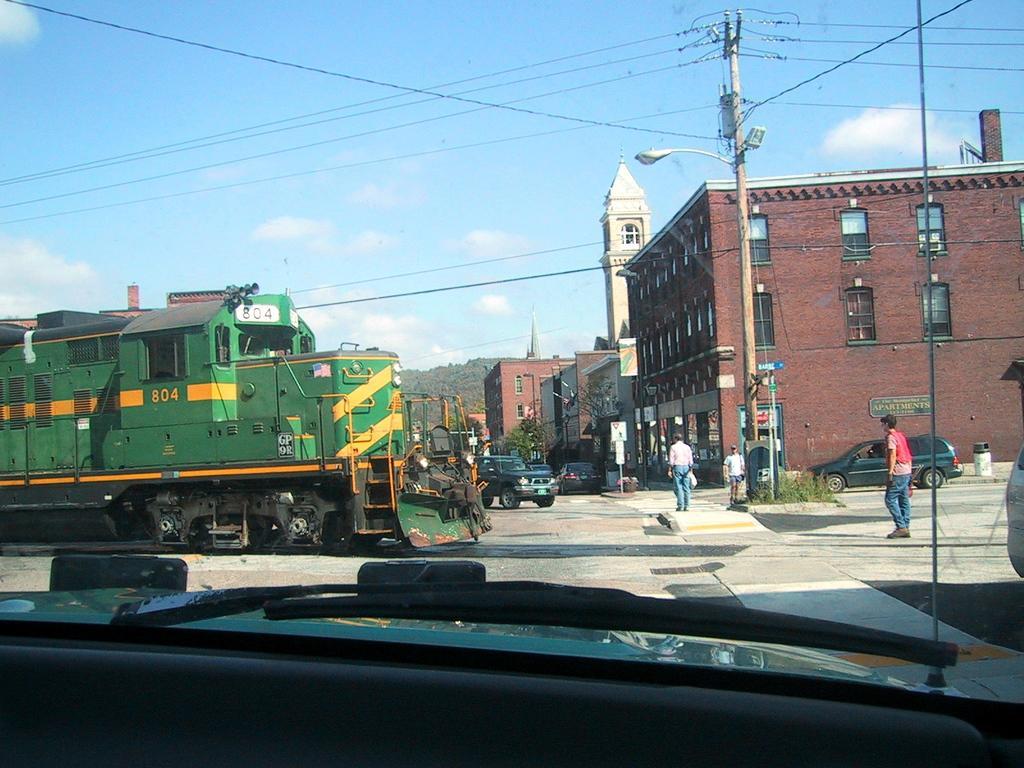Can you describe this image briefly? In the picture we can see a street, in the street we can see a train on the track which is green in color with some yellow lines and besides, we can see some people standing on the path near to the buildings and we can also see some poles, street lights, wires to the poles and sky with a cloud. 